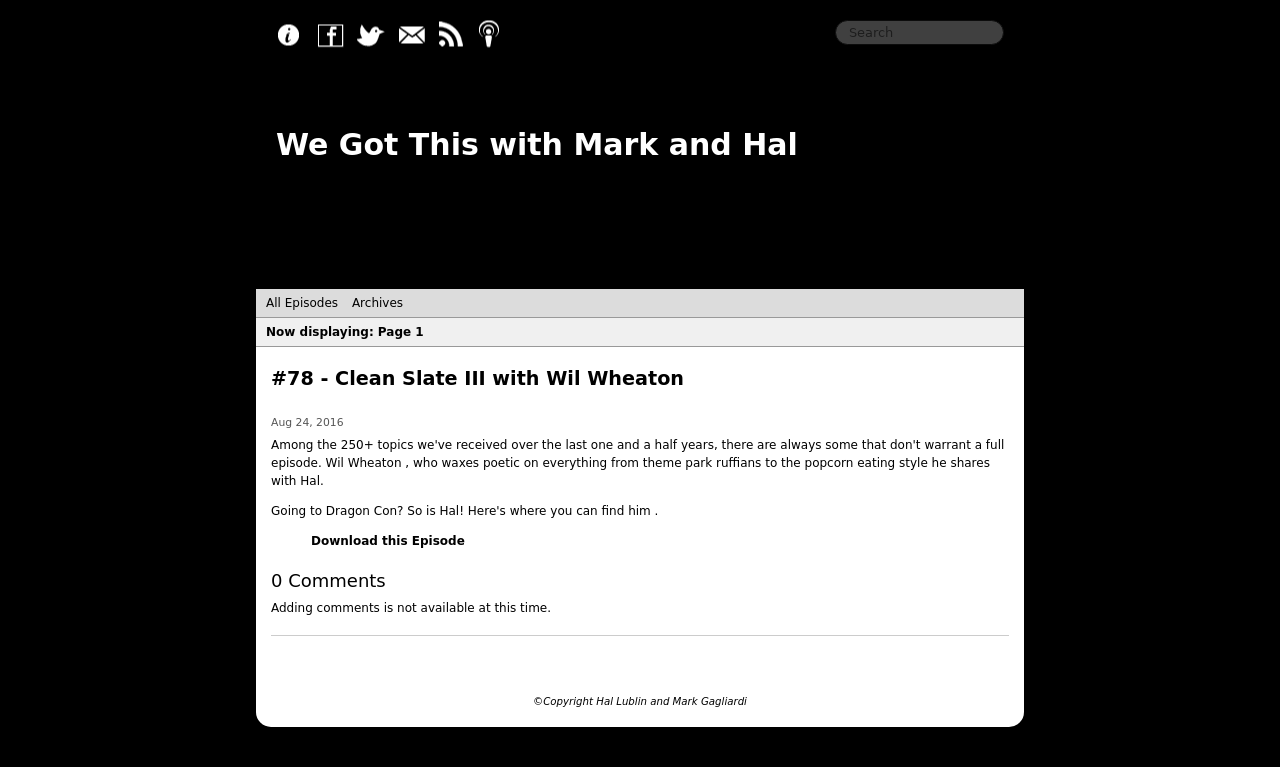Could you describe the visual theme or style of the website displayed in the image? Certainly! The website design depicted is minimalist and clean, focusing on ease of navigation and readability. The color scheme is predominantly black and white, creating a stark contrast that aids in emphasizing specific information. The layout is organized and uncluttered, highlighting essential elements like episode listings and navigation links, all while maintaining a professional and modern aesthetic. 